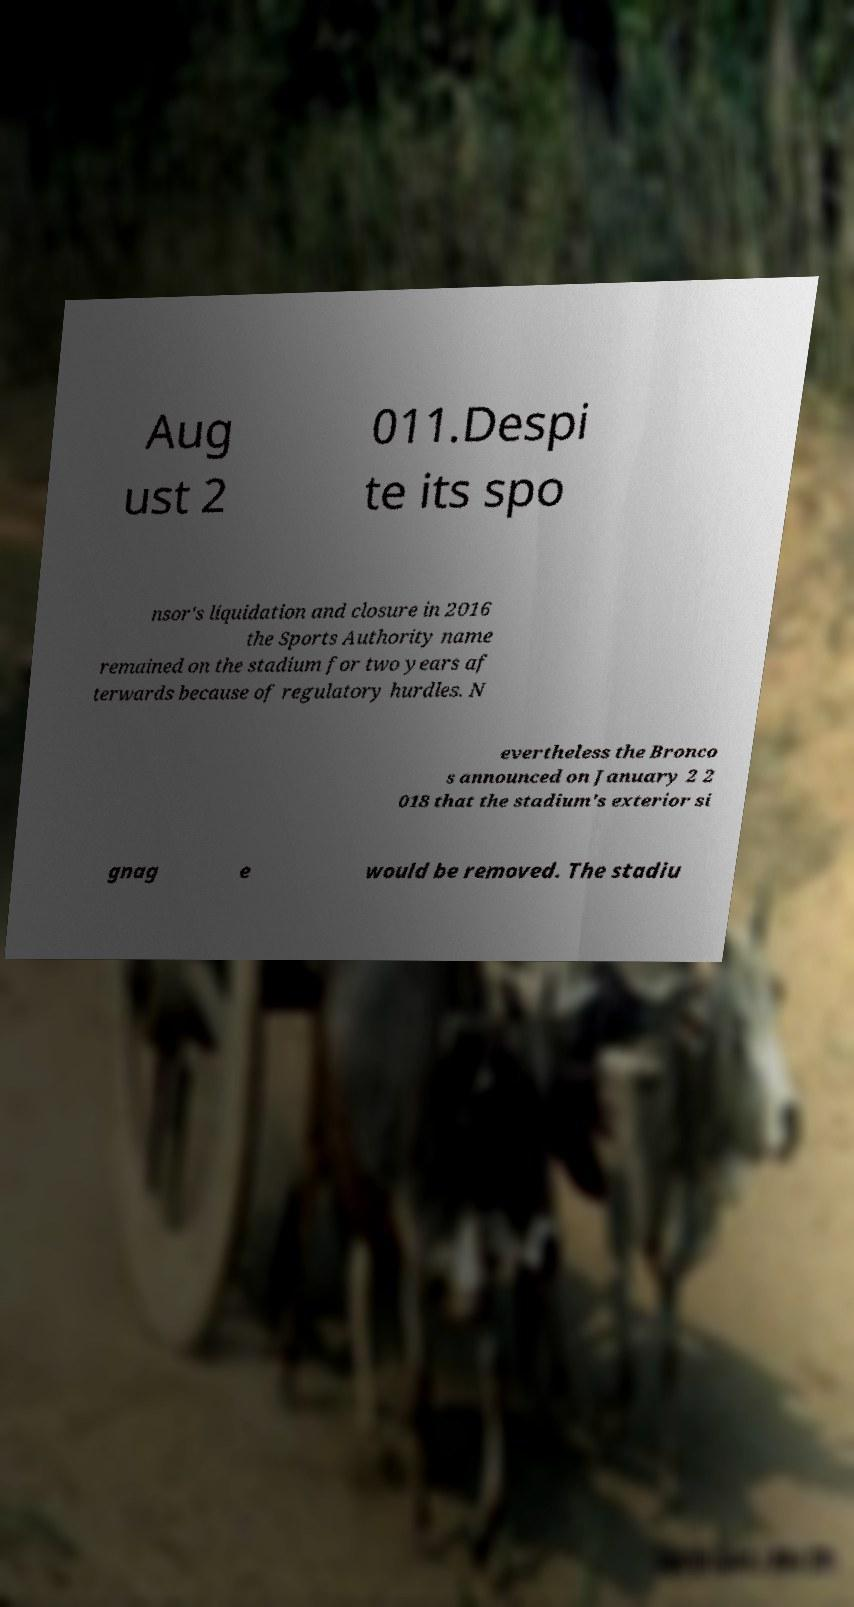What messages or text are displayed in this image? I need them in a readable, typed format. Aug ust 2 011.Despi te its spo nsor's liquidation and closure in 2016 the Sports Authority name remained on the stadium for two years af terwards because of regulatory hurdles. N evertheless the Bronco s announced on January 2 2 018 that the stadium's exterior si gnag e would be removed. The stadiu 